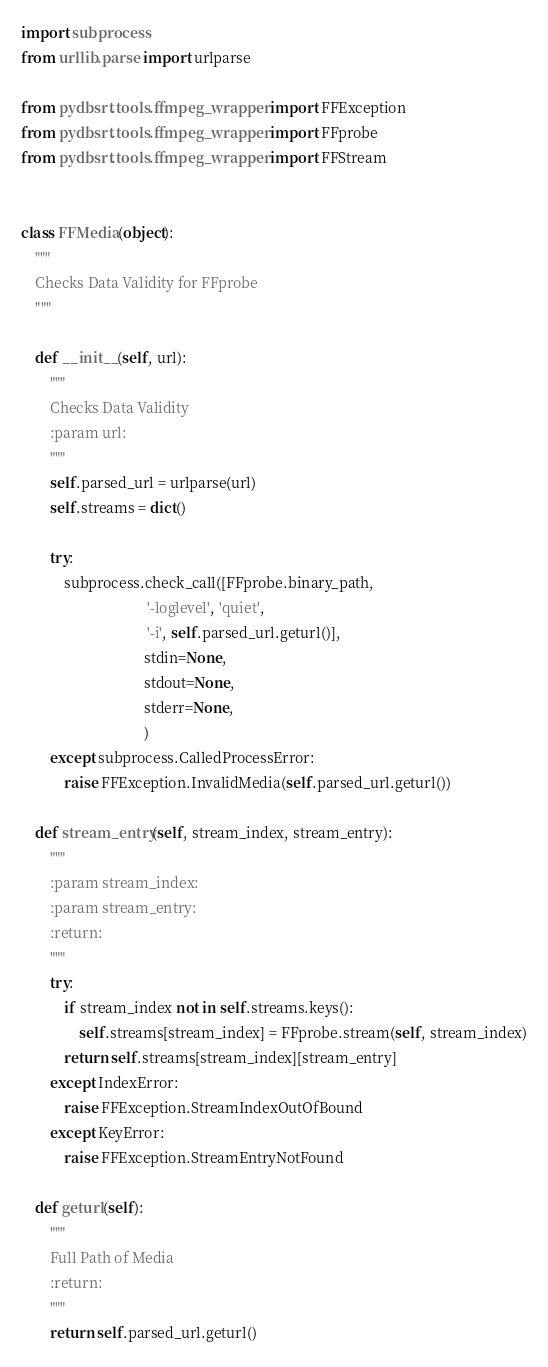<code> <loc_0><loc_0><loc_500><loc_500><_Python_>import subprocess
from urllib.parse import urlparse

from pydbsrt.tools.ffmpeg_wrapper import FFException
from pydbsrt.tools.ffmpeg_wrapper import FFprobe
from pydbsrt.tools.ffmpeg_wrapper import FFStream


class FFMedia(object):
    """
    Checks Data Validity for FFprobe
    """

    def __init__(self, url):
        """
        Checks Data Validity
        :param url:
        """
        self.parsed_url = urlparse(url)
        self.streams = dict()

        try:
            subprocess.check_call([FFprobe.binary_path,
                                   '-loglevel', 'quiet',
                                   '-i', self.parsed_url.geturl()],
                                  stdin=None,
                                  stdout=None,
                                  stderr=None,
                                  )
        except subprocess.CalledProcessError:
            raise FFException.InvalidMedia(self.parsed_url.geturl())

    def stream_entry(self, stream_index, stream_entry):
        """
        :param stream_index:
        :param stream_entry:
        :return:
        """
        try:
            if stream_index not in self.streams.keys():
                self.streams[stream_index] = FFprobe.stream(self, stream_index)
            return self.streams[stream_index][stream_entry]
        except IndexError:
            raise FFException.StreamIndexOutOfBound
        except KeyError:
            raise FFException.StreamEntryNotFound

    def geturl(self):
        """
        Full Path of Media
        :return:
        """
        return self.parsed_url.geturl()
</code> 